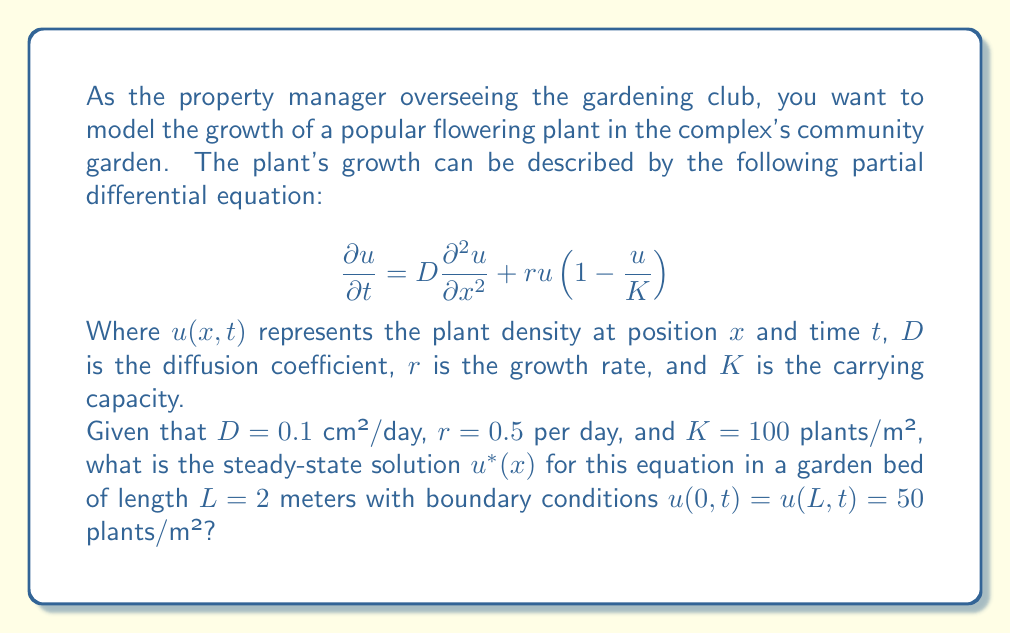Teach me how to tackle this problem. To solve this problem, we need to follow these steps:

1) For the steady-state solution, the plant density doesn't change with time. So, we set $\frac{\partial u}{\partial t} = 0$:

   $$0 = D\frac{d^2 u^*}{dx^2} + ru^*(1-\frac{u^*}{K})$$

2) Substitute the given values:

   $$0 = 0.1\frac{d^2 u^*}{dx^2} + 0.5u^*(1-\frac{u^*}{100})$$

3) This is a second-order nonlinear differential equation. However, we can simplify it by noticing that $u^* = K = 100$ is a constant solution that satisfies the equation:

   $$0 = 0.1\frac{d^2 (100)}{dx^2} + 0.5(100)(1-\frac{100}{100}) = 0 + 0 = 0$$

4) This constant solution also satisfies our boundary conditions at $x = 0$ and $x = L$:

   $$u^*(0) = u^*(2) = 50 \text{ plants/m²}$$

5) Therefore, the steady-state solution is a straight line connecting these two boundary points:

   $$u^*(x) = 50 + \frac{50-50}{2-0}(x-0) = 50 \text{ plants/m²}$$

This constant solution represents a uniform distribution of plants across the garden bed, which is a reasonable steady-state for a well-managed community garden.
Answer: The steady-state solution is $u^*(x) = 50$ plants/m² for all $x$ in $[0, 2]$ meters. 